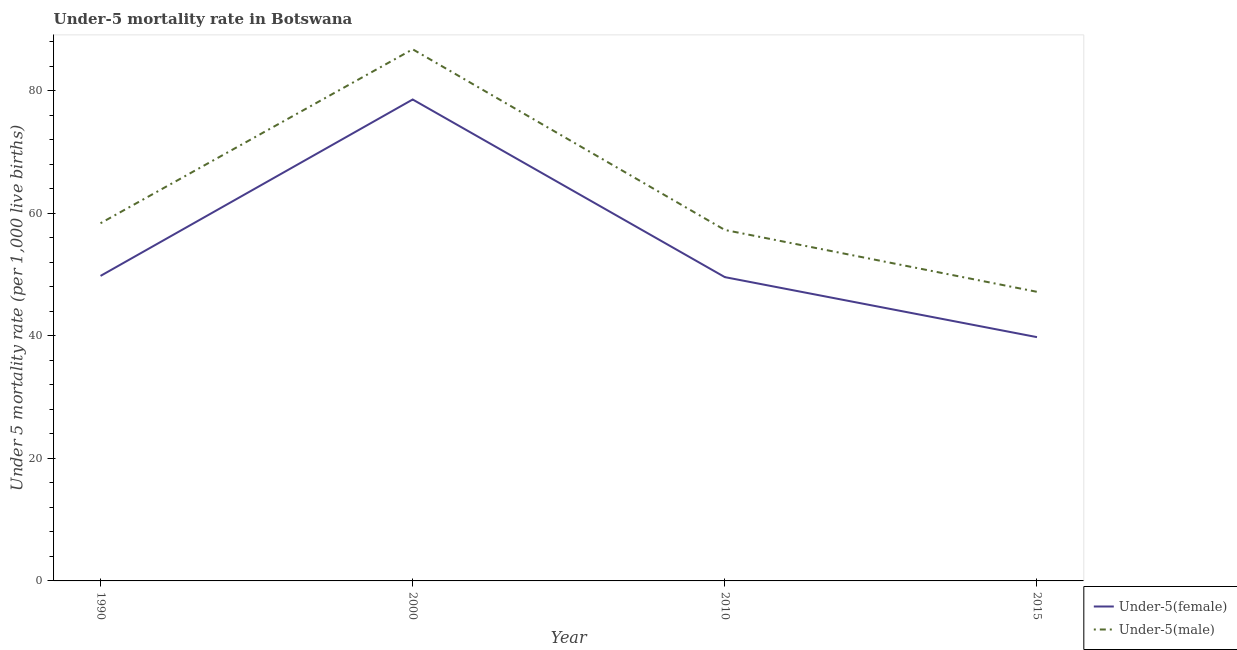Does the line corresponding to under-5 female mortality rate intersect with the line corresponding to under-5 male mortality rate?
Your response must be concise. No. What is the under-5 female mortality rate in 1990?
Offer a very short reply. 49.8. Across all years, what is the maximum under-5 male mortality rate?
Offer a terse response. 86.8. Across all years, what is the minimum under-5 female mortality rate?
Your answer should be very brief. 39.8. In which year was the under-5 female mortality rate minimum?
Keep it short and to the point. 2015. What is the total under-5 male mortality rate in the graph?
Ensure brevity in your answer.  249.7. What is the difference between the under-5 male mortality rate in 2000 and that in 2010?
Give a very brief answer. 29.5. What is the difference between the under-5 female mortality rate in 2015 and the under-5 male mortality rate in 2010?
Your response must be concise. -17.5. What is the average under-5 female mortality rate per year?
Provide a succinct answer. 54.45. In the year 2010, what is the difference between the under-5 female mortality rate and under-5 male mortality rate?
Provide a succinct answer. -7.7. What is the ratio of the under-5 female mortality rate in 2000 to that in 2010?
Provide a short and direct response. 1.58. Is the difference between the under-5 female mortality rate in 2000 and 2010 greater than the difference between the under-5 male mortality rate in 2000 and 2010?
Your response must be concise. No. What is the difference between the highest and the second highest under-5 female mortality rate?
Ensure brevity in your answer.  28.8. What is the difference between the highest and the lowest under-5 male mortality rate?
Your answer should be compact. 39.6. In how many years, is the under-5 female mortality rate greater than the average under-5 female mortality rate taken over all years?
Your response must be concise. 1. Is the sum of the under-5 female mortality rate in 2000 and 2010 greater than the maximum under-5 male mortality rate across all years?
Provide a succinct answer. Yes. Does the under-5 male mortality rate monotonically increase over the years?
Your answer should be very brief. No. Is the under-5 female mortality rate strictly greater than the under-5 male mortality rate over the years?
Keep it short and to the point. No. How many years are there in the graph?
Provide a succinct answer. 4. What is the difference between two consecutive major ticks on the Y-axis?
Give a very brief answer. 20. Are the values on the major ticks of Y-axis written in scientific E-notation?
Keep it short and to the point. No. Does the graph contain any zero values?
Your answer should be compact. No. Does the graph contain grids?
Your response must be concise. No. How many legend labels are there?
Your response must be concise. 2. What is the title of the graph?
Keep it short and to the point. Under-5 mortality rate in Botswana. What is the label or title of the X-axis?
Offer a terse response. Year. What is the label or title of the Y-axis?
Provide a short and direct response. Under 5 mortality rate (per 1,0 live births). What is the Under 5 mortality rate (per 1,000 live births) of Under-5(female) in 1990?
Offer a terse response. 49.8. What is the Under 5 mortality rate (per 1,000 live births) of Under-5(male) in 1990?
Provide a succinct answer. 58.4. What is the Under 5 mortality rate (per 1,000 live births) in Under-5(female) in 2000?
Your response must be concise. 78.6. What is the Under 5 mortality rate (per 1,000 live births) in Under-5(male) in 2000?
Offer a very short reply. 86.8. What is the Under 5 mortality rate (per 1,000 live births) of Under-5(female) in 2010?
Give a very brief answer. 49.6. What is the Under 5 mortality rate (per 1,000 live births) in Under-5(male) in 2010?
Provide a short and direct response. 57.3. What is the Under 5 mortality rate (per 1,000 live births) in Under-5(female) in 2015?
Keep it short and to the point. 39.8. What is the Under 5 mortality rate (per 1,000 live births) of Under-5(male) in 2015?
Ensure brevity in your answer.  47.2. Across all years, what is the maximum Under 5 mortality rate (per 1,000 live births) of Under-5(female)?
Make the answer very short. 78.6. Across all years, what is the maximum Under 5 mortality rate (per 1,000 live births) of Under-5(male)?
Your answer should be very brief. 86.8. Across all years, what is the minimum Under 5 mortality rate (per 1,000 live births) of Under-5(female)?
Make the answer very short. 39.8. Across all years, what is the minimum Under 5 mortality rate (per 1,000 live births) of Under-5(male)?
Provide a succinct answer. 47.2. What is the total Under 5 mortality rate (per 1,000 live births) in Under-5(female) in the graph?
Ensure brevity in your answer.  217.8. What is the total Under 5 mortality rate (per 1,000 live births) in Under-5(male) in the graph?
Your answer should be compact. 249.7. What is the difference between the Under 5 mortality rate (per 1,000 live births) of Under-5(female) in 1990 and that in 2000?
Ensure brevity in your answer.  -28.8. What is the difference between the Under 5 mortality rate (per 1,000 live births) of Under-5(male) in 1990 and that in 2000?
Offer a terse response. -28.4. What is the difference between the Under 5 mortality rate (per 1,000 live births) of Under-5(female) in 1990 and that in 2010?
Give a very brief answer. 0.2. What is the difference between the Under 5 mortality rate (per 1,000 live births) of Under-5(male) in 1990 and that in 2010?
Give a very brief answer. 1.1. What is the difference between the Under 5 mortality rate (per 1,000 live births) of Under-5(male) in 1990 and that in 2015?
Your response must be concise. 11.2. What is the difference between the Under 5 mortality rate (per 1,000 live births) in Under-5(male) in 2000 and that in 2010?
Ensure brevity in your answer.  29.5. What is the difference between the Under 5 mortality rate (per 1,000 live births) of Under-5(female) in 2000 and that in 2015?
Your answer should be compact. 38.8. What is the difference between the Under 5 mortality rate (per 1,000 live births) in Under-5(male) in 2000 and that in 2015?
Offer a very short reply. 39.6. What is the difference between the Under 5 mortality rate (per 1,000 live births) in Under-5(female) in 2010 and that in 2015?
Your response must be concise. 9.8. What is the difference between the Under 5 mortality rate (per 1,000 live births) of Under-5(male) in 2010 and that in 2015?
Provide a succinct answer. 10.1. What is the difference between the Under 5 mortality rate (per 1,000 live births) of Under-5(female) in 1990 and the Under 5 mortality rate (per 1,000 live births) of Under-5(male) in 2000?
Offer a terse response. -37. What is the difference between the Under 5 mortality rate (per 1,000 live births) of Under-5(female) in 1990 and the Under 5 mortality rate (per 1,000 live births) of Under-5(male) in 2015?
Provide a succinct answer. 2.6. What is the difference between the Under 5 mortality rate (per 1,000 live births) of Under-5(female) in 2000 and the Under 5 mortality rate (per 1,000 live births) of Under-5(male) in 2010?
Make the answer very short. 21.3. What is the difference between the Under 5 mortality rate (per 1,000 live births) of Under-5(female) in 2000 and the Under 5 mortality rate (per 1,000 live births) of Under-5(male) in 2015?
Make the answer very short. 31.4. What is the difference between the Under 5 mortality rate (per 1,000 live births) of Under-5(female) in 2010 and the Under 5 mortality rate (per 1,000 live births) of Under-5(male) in 2015?
Provide a short and direct response. 2.4. What is the average Under 5 mortality rate (per 1,000 live births) of Under-5(female) per year?
Your answer should be compact. 54.45. What is the average Under 5 mortality rate (per 1,000 live births) of Under-5(male) per year?
Your answer should be compact. 62.42. In the year 1990, what is the difference between the Under 5 mortality rate (per 1,000 live births) of Under-5(female) and Under 5 mortality rate (per 1,000 live births) of Under-5(male)?
Keep it short and to the point. -8.6. What is the ratio of the Under 5 mortality rate (per 1,000 live births) of Under-5(female) in 1990 to that in 2000?
Offer a very short reply. 0.63. What is the ratio of the Under 5 mortality rate (per 1,000 live births) of Under-5(male) in 1990 to that in 2000?
Offer a very short reply. 0.67. What is the ratio of the Under 5 mortality rate (per 1,000 live births) of Under-5(female) in 1990 to that in 2010?
Keep it short and to the point. 1. What is the ratio of the Under 5 mortality rate (per 1,000 live births) of Under-5(male) in 1990 to that in 2010?
Your answer should be very brief. 1.02. What is the ratio of the Under 5 mortality rate (per 1,000 live births) of Under-5(female) in 1990 to that in 2015?
Provide a succinct answer. 1.25. What is the ratio of the Under 5 mortality rate (per 1,000 live births) of Under-5(male) in 1990 to that in 2015?
Provide a succinct answer. 1.24. What is the ratio of the Under 5 mortality rate (per 1,000 live births) of Under-5(female) in 2000 to that in 2010?
Provide a short and direct response. 1.58. What is the ratio of the Under 5 mortality rate (per 1,000 live births) of Under-5(male) in 2000 to that in 2010?
Offer a very short reply. 1.51. What is the ratio of the Under 5 mortality rate (per 1,000 live births) in Under-5(female) in 2000 to that in 2015?
Offer a terse response. 1.97. What is the ratio of the Under 5 mortality rate (per 1,000 live births) in Under-5(male) in 2000 to that in 2015?
Offer a very short reply. 1.84. What is the ratio of the Under 5 mortality rate (per 1,000 live births) of Under-5(female) in 2010 to that in 2015?
Offer a terse response. 1.25. What is the ratio of the Under 5 mortality rate (per 1,000 live births) of Under-5(male) in 2010 to that in 2015?
Provide a short and direct response. 1.21. What is the difference between the highest and the second highest Under 5 mortality rate (per 1,000 live births) in Under-5(female)?
Ensure brevity in your answer.  28.8. What is the difference between the highest and the second highest Under 5 mortality rate (per 1,000 live births) in Under-5(male)?
Your answer should be compact. 28.4. What is the difference between the highest and the lowest Under 5 mortality rate (per 1,000 live births) of Under-5(female)?
Provide a succinct answer. 38.8. What is the difference between the highest and the lowest Under 5 mortality rate (per 1,000 live births) of Under-5(male)?
Offer a very short reply. 39.6. 